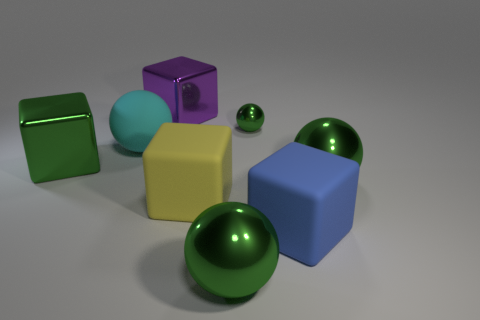Subtract all green cubes. How many green spheres are left? 3 Subtract 1 balls. How many balls are left? 3 Add 1 tiny green objects. How many objects exist? 9 Subtract 0 yellow balls. How many objects are left? 8 Subtract all big green rubber spheres. Subtract all cyan objects. How many objects are left? 7 Add 2 green metal cubes. How many green metal cubes are left? 3 Add 5 green metallic balls. How many green metallic balls exist? 8 